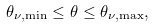<formula> <loc_0><loc_0><loc_500><loc_500>\theta _ { \nu , \min } \leq \theta \leq \theta _ { \nu , \max } ,</formula> 